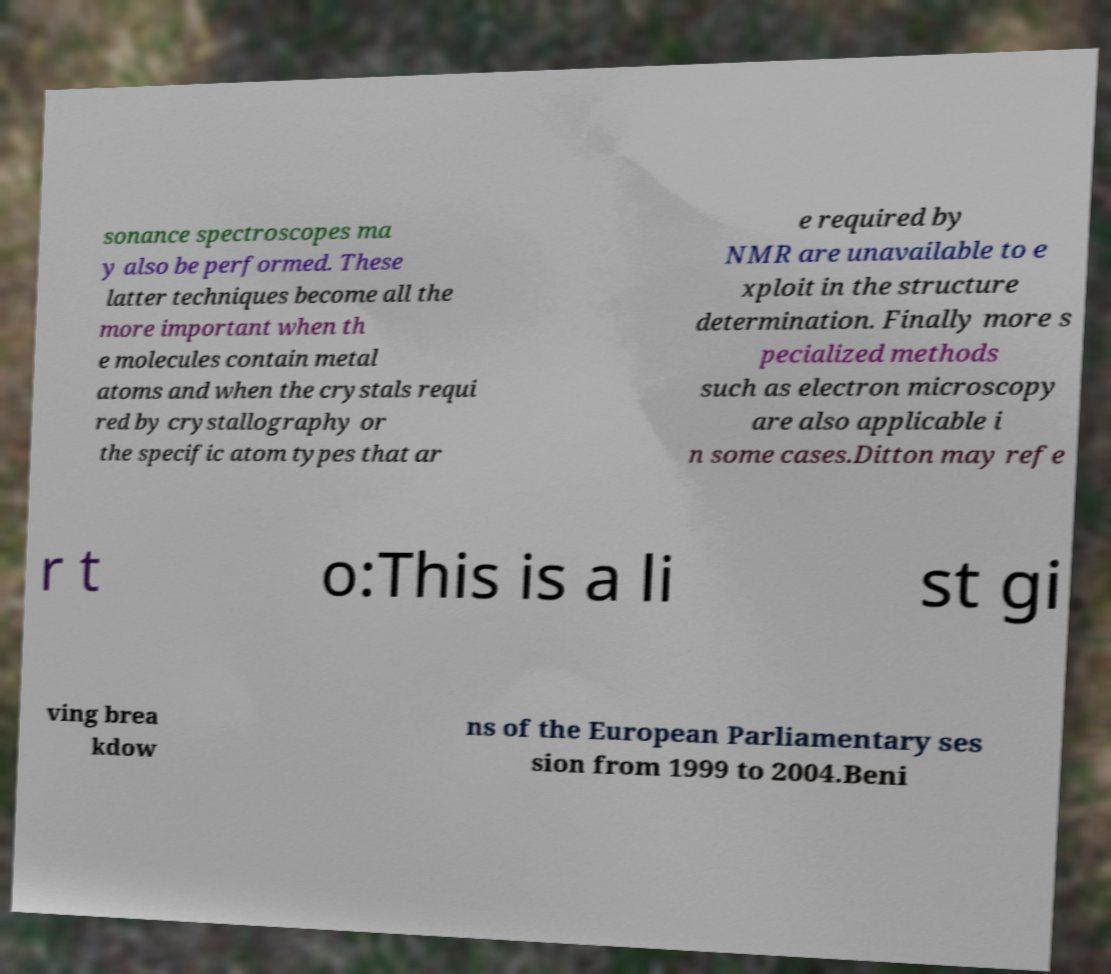Please identify and transcribe the text found in this image. sonance spectroscopes ma y also be performed. These latter techniques become all the more important when th e molecules contain metal atoms and when the crystals requi red by crystallography or the specific atom types that ar e required by NMR are unavailable to e xploit in the structure determination. Finally more s pecialized methods such as electron microscopy are also applicable i n some cases.Ditton may refe r t o:This is a li st gi ving brea kdow ns of the European Parliamentary ses sion from 1999 to 2004.Beni 